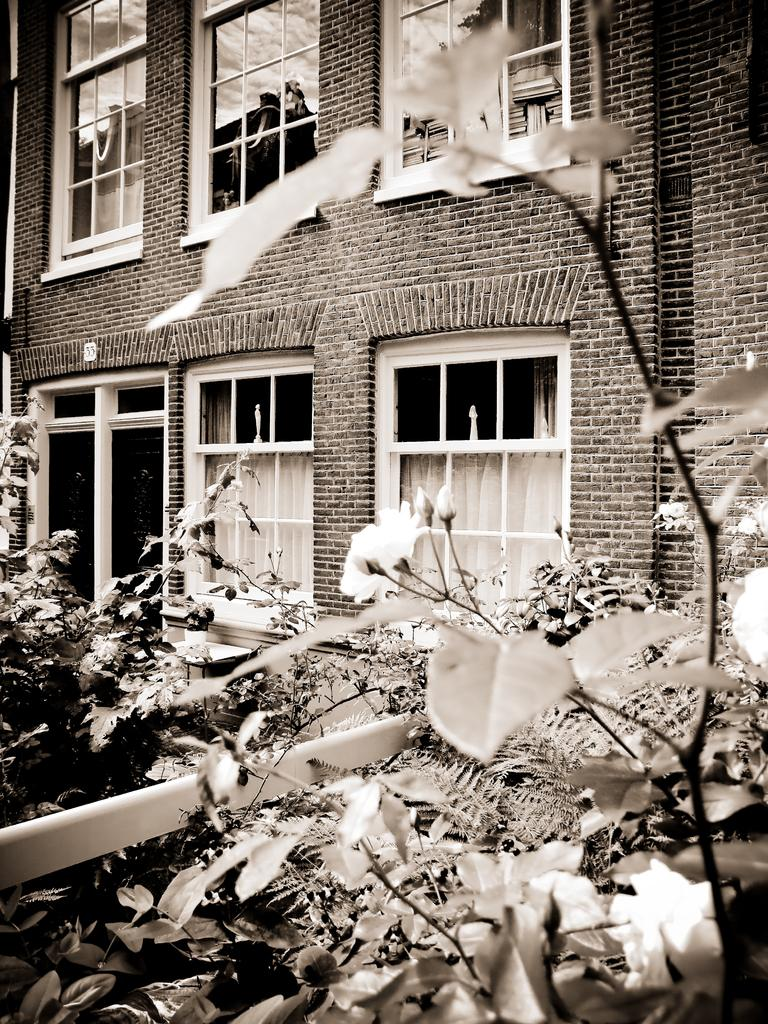What types of vegetation can be seen in the front of the image? There are flowers and plants in the front of the image. What type of structure is visible in the background of the image? There is a building in the background of the image. What architectural feature can be seen in the background of the image? There are windows visible in the background of the image. Reasoning: Let's think step by step by step in order to produce the conversation. We start by identifying the main subjects in the image, which are the flowers and plants in the front. Then, we expand the conversation to include the building and windows in the background. Each question is designed to elicit a specific detail about the image that is known from the provided facts. Absurd Question/Answer: What type of oranges are being served for dinner in the image? There are no oranges or dinner present in the image. Are the trousers visible in the image? There is no mention of trousers or any clothing items in the image. What is the person in the image doing? The person is sitting on a chair in the image. What object is the person holding? The person is holding a book. What furniture is located next to the chair? There is a table next to the chair. What is on the table? There is a lamp on the table. What is the lighting condition in the image? The background of the image is dark. Reasoning: Let's think step by step in order to produce the conversation. We start by identifying the main subject in the image, which is the person sitting on a chair. Then, we expand the conversation to include the book, table, lamp, and the dark background. Each question is designed to elicit a specific detail about the image that is known from the provided facts. Absurd Question/Answer: Can you see the elephant swimming in the ocean in the image? There is no elephant or ocean present 